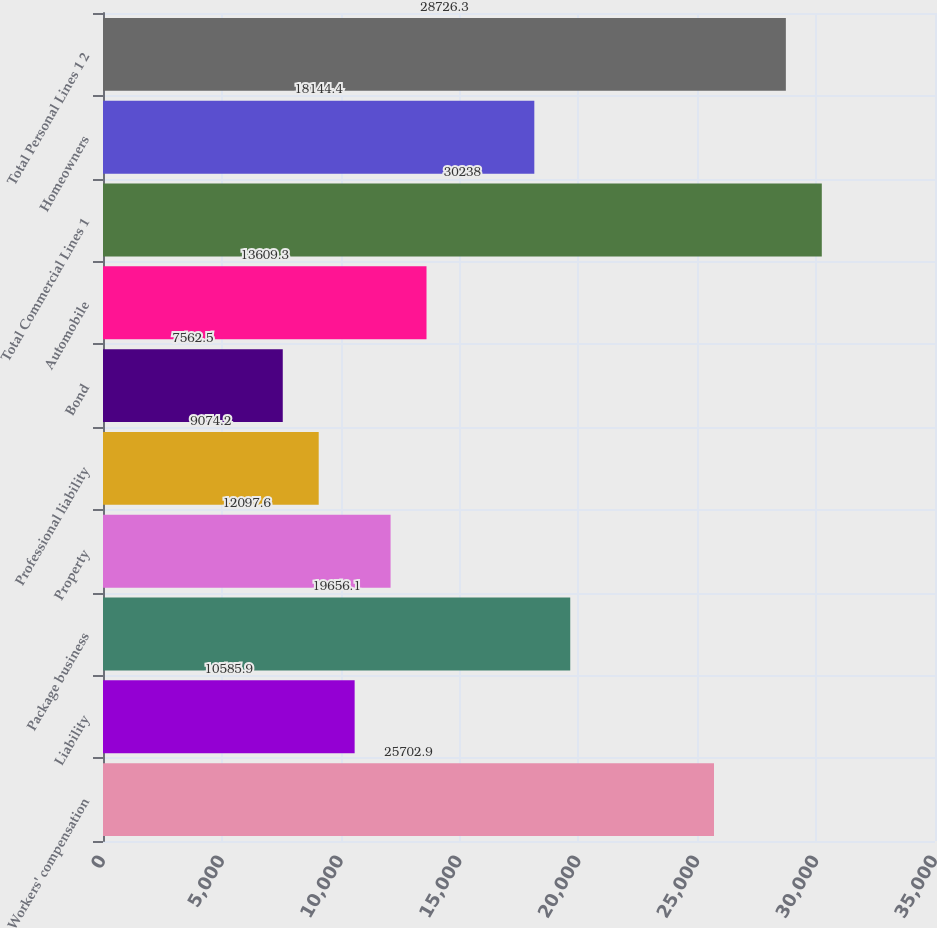Convert chart to OTSL. <chart><loc_0><loc_0><loc_500><loc_500><bar_chart><fcel>Workers' compensation<fcel>Liability<fcel>Package business<fcel>Property<fcel>Professional liability<fcel>Bond<fcel>Automobile<fcel>Total Commercial Lines 1<fcel>Homeowners<fcel>Total Personal Lines 1 2<nl><fcel>25702.9<fcel>10585.9<fcel>19656.1<fcel>12097.6<fcel>9074.2<fcel>7562.5<fcel>13609.3<fcel>30238<fcel>18144.4<fcel>28726.3<nl></chart> 